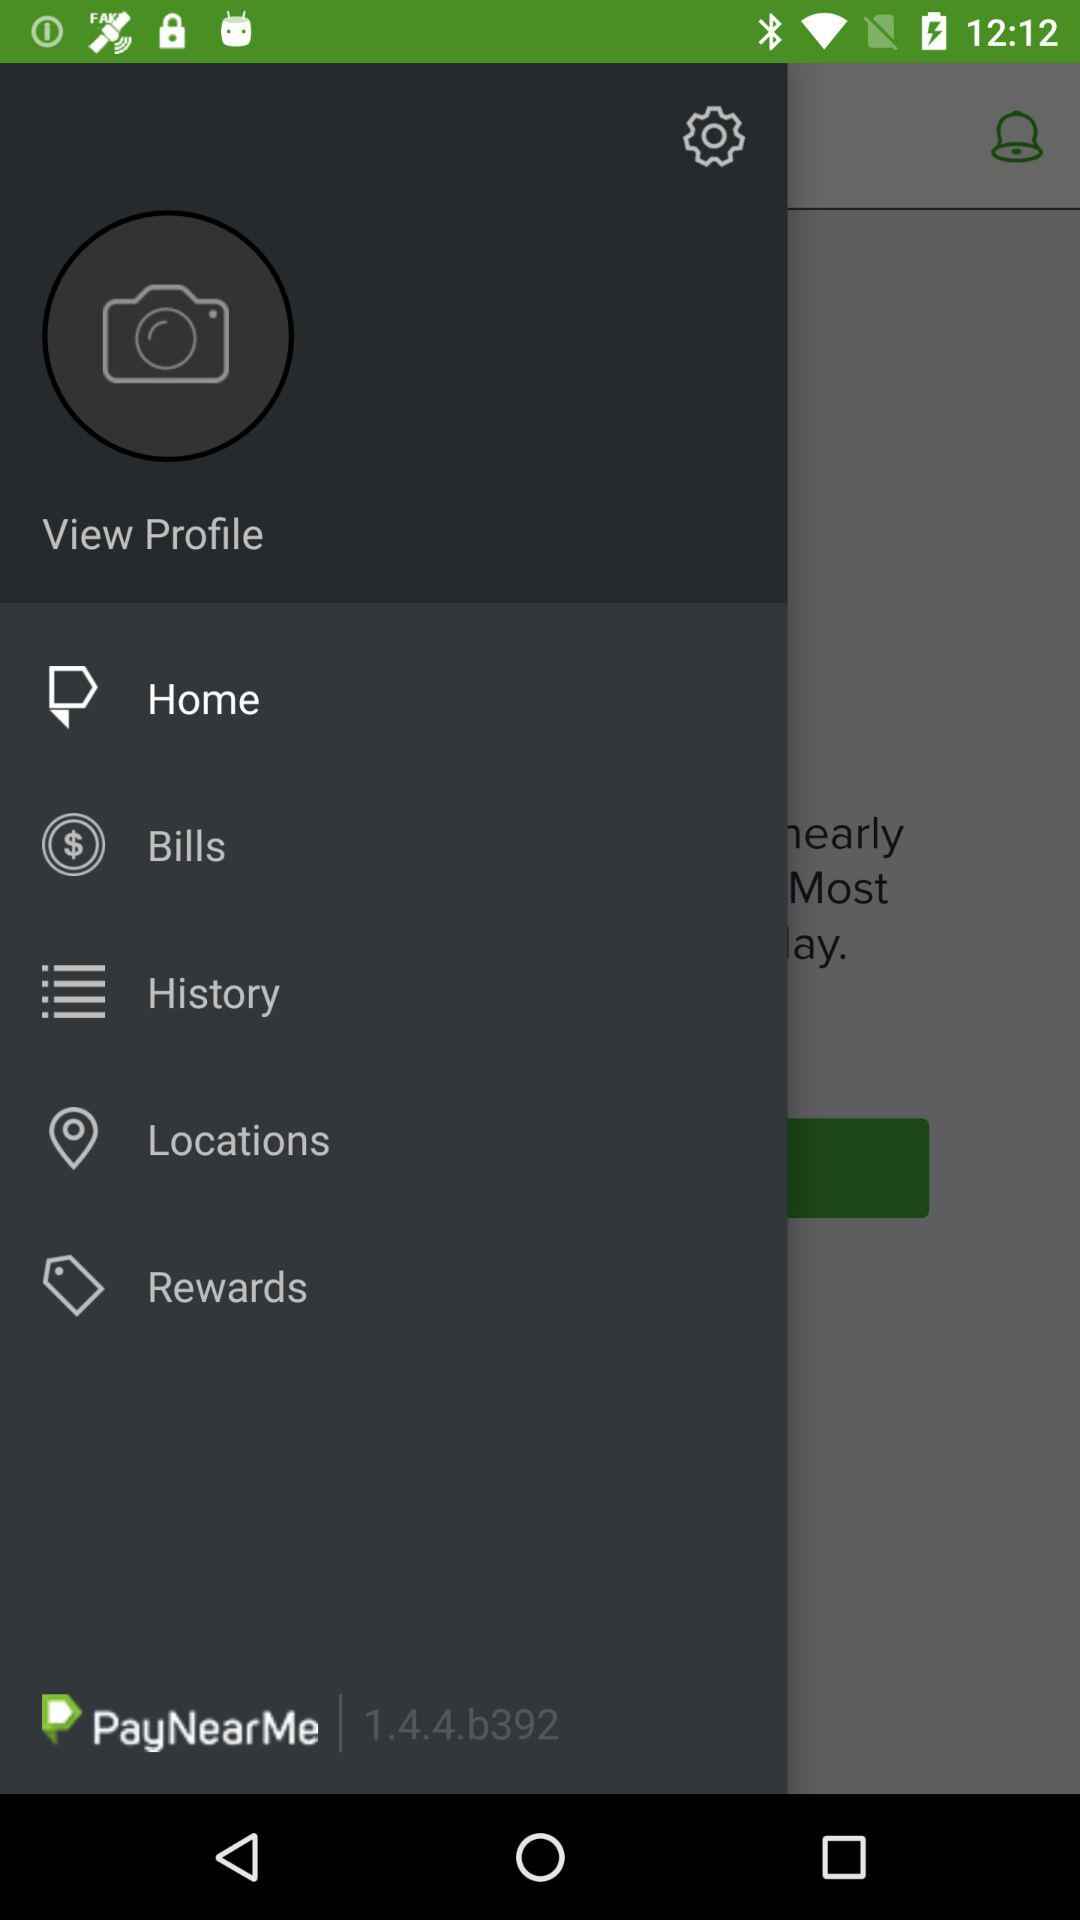What is the application name? The application name is "PayNearMe". 